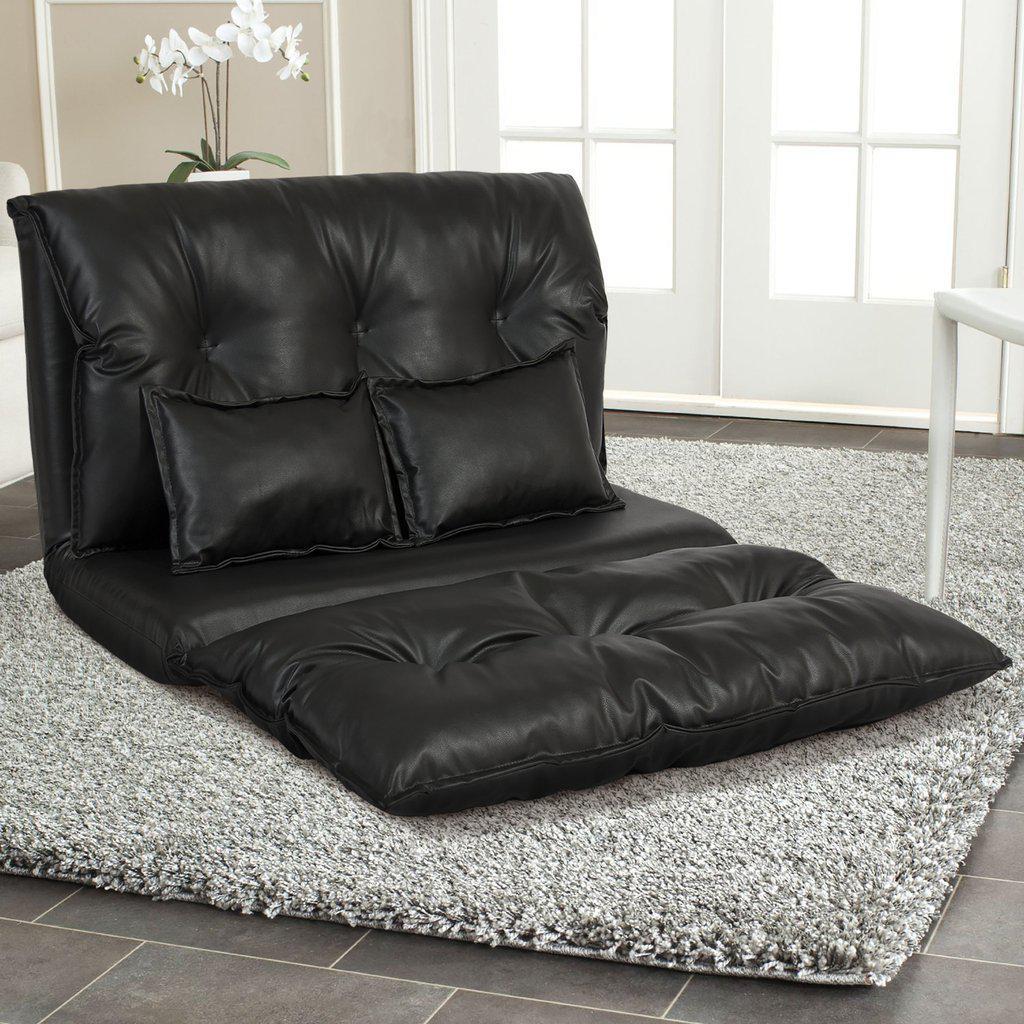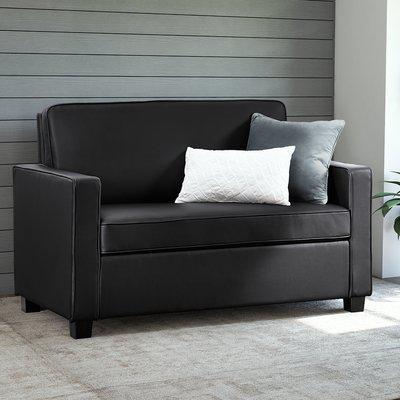The first image is the image on the left, the second image is the image on the right. Examine the images to the left and right. Is the description "A solid color loveseat on short legs with two throw pillows is in one image, with the other image showing a wide black tufted floor lounger with two matching pillows." accurate? Answer yes or no. Yes. The first image is the image on the left, the second image is the image on the right. Evaluate the accuracy of this statement regarding the images: "A tufted black cushion sits like a chair without legs and has two black throw pillows on it.". Is it true? Answer yes or no. Yes. 